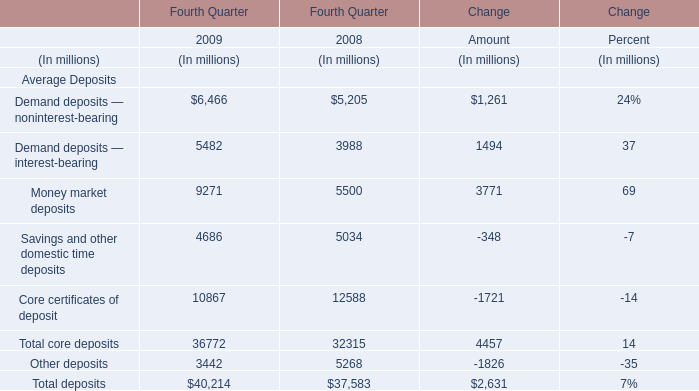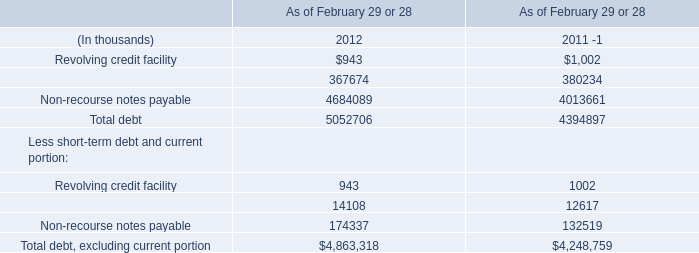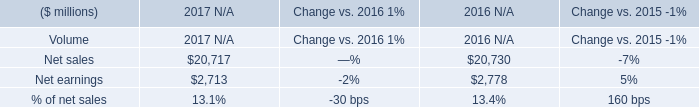What was the total amount of the Money market deposits in the years where Demand deposits — noninterest-bearing is greater than 5000? (in million) 
Computations: (9271 + 5500)
Answer: 14771.0. 